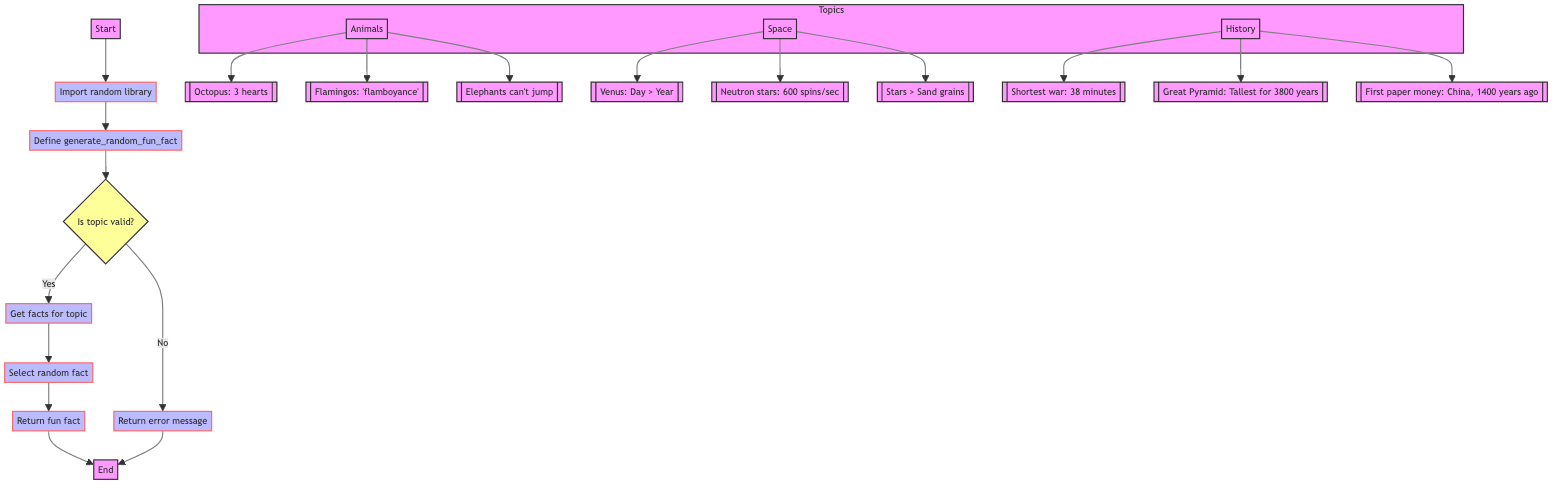What does the function generate? The function's primary purpose is to generate a random fun fact based on a specific topic provided as input. This is evident from the function name and the return statement in the diagram.
Answer: random fun fact Which library is imported first? The flowchart indicates that the first step in the diagram is the importation of the random library. This is crucial for the function's ability to select a random fact later on.
Answer: random How many topics are included in the function? The function includes three predefined topics as shown in the subgraph: animals, space, and history. Each topic correlates with a set of fun facts.
Answer: three What happens if an invalid topic is provided? If the provided topic is invalid, the function will return an error message, as described in the flowchart diagram under the decision node for topic validity.
Answer: return error message How does the function select a random fact? The function uses the random library to select a fact from the list associated with a valid topic. This is detailed in the flowchart after confirming the topic validity.
Answer: select random fact What is the purpose of the decision node in the flowchart? The decision node in the flowchart checks whether the provided topic is valid or not, determining the next steps in the function's execution based on this validity.
Answer: to check topic validity What fun fact relates to the topic of space? One of the fun facts related to space, represented in the diagram, is that a day on Venus is longer than a year on Venus. This fact is included in the facts for the space topic.
Answer: A day on Venus is longer than a year on Venus Which node leads to returning a fun fact? The node that leads to returning a fun fact is directly after the node where a random fact has been selected, indicating the flow of the function toward the return statement.
Answer: Return fun fact 